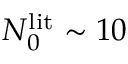Convert formula to latex. <formula><loc_0><loc_0><loc_500><loc_500>N _ { 0 } ^ { l i t } \sim 1 0</formula> 